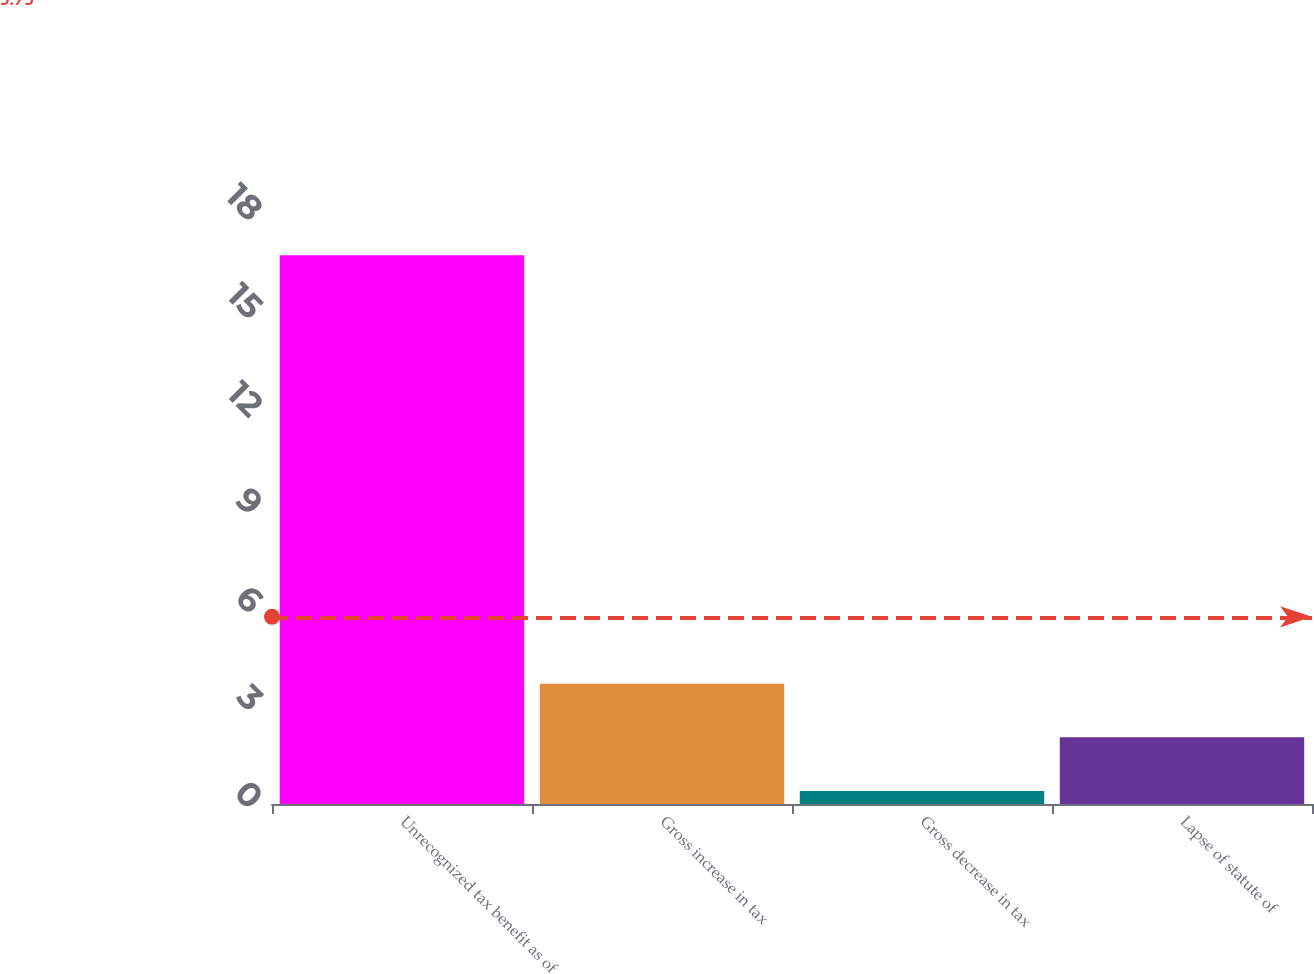Convert chart. <chart><loc_0><loc_0><loc_500><loc_500><bar_chart><fcel>Unrecognized tax benefit as of<fcel>Gross increase in tax<fcel>Gross decrease in tax<fcel>Lapse of statute of<nl><fcel>16.8<fcel>3.68<fcel>0.4<fcel>2.04<nl></chart> 